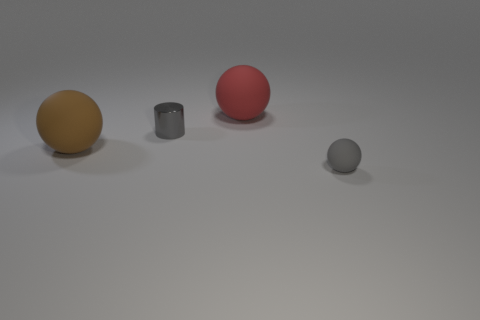There is a matte thing that is behind the gray metal cylinder; what size is it?
Your answer should be very brief. Large. There is a gray thing behind the tiny object right of the tiny metallic thing; how big is it?
Keep it short and to the point. Small. Is the number of brown balls right of the big brown matte ball greater than the number of big green matte cubes?
Give a very brief answer. No. Is the size of the thing to the left of the cylinder the same as the large red matte object?
Keep it short and to the point. Yes. There is a sphere that is both to the right of the small metal cylinder and in front of the small gray metallic cylinder; what is its color?
Offer a very short reply. Gray. What shape is the other object that is the same size as the red rubber thing?
Provide a short and direct response. Sphere. Is there a small thing of the same color as the shiny cylinder?
Your answer should be compact. Yes. Are there the same number of spheres in front of the brown ball and small brown metal cubes?
Make the answer very short. No. Is the color of the small matte object the same as the tiny cylinder?
Offer a very short reply. Yes. There is a rubber sphere that is in front of the small gray cylinder and on the right side of the big brown matte ball; what is its size?
Ensure brevity in your answer.  Small. 